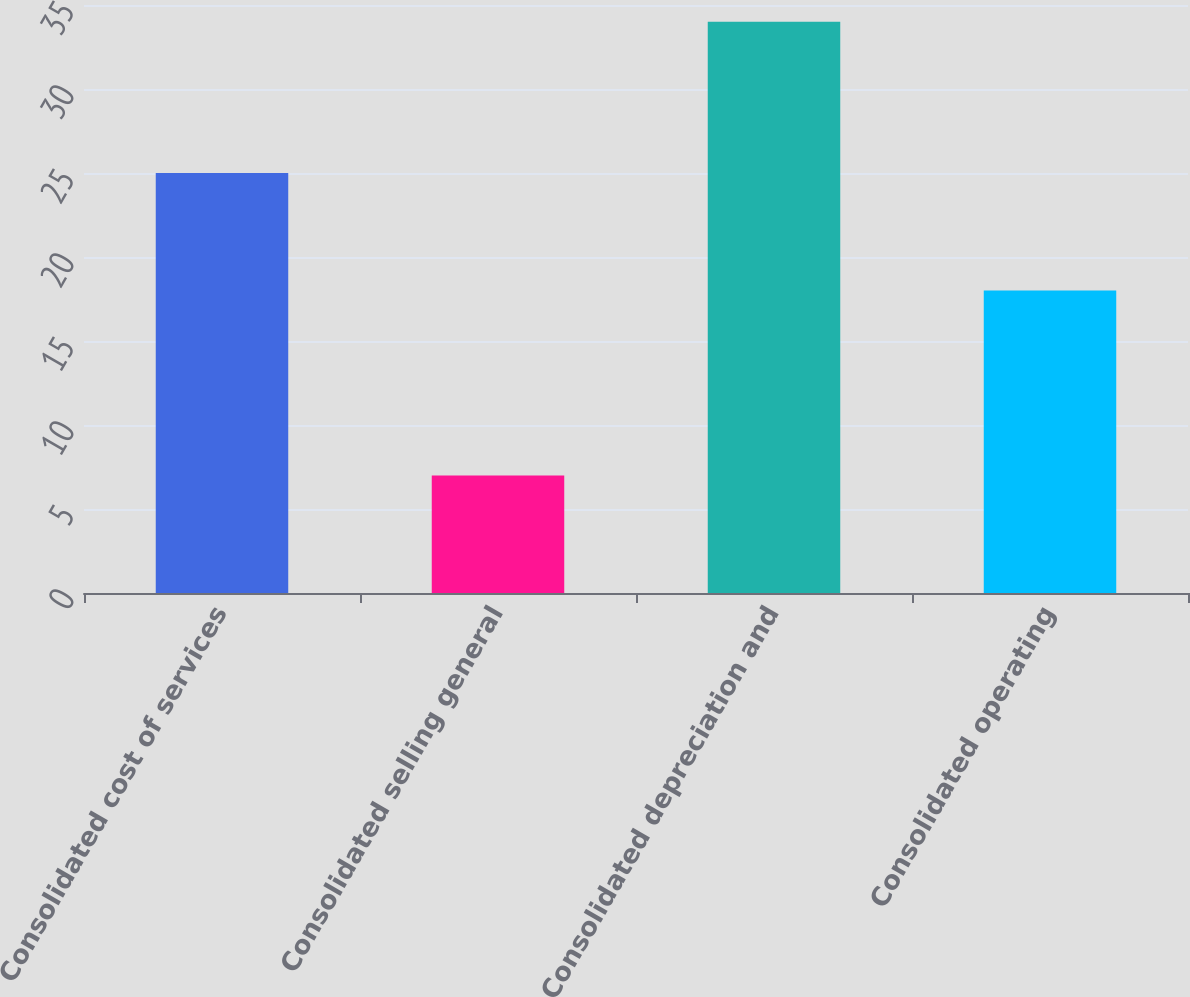<chart> <loc_0><loc_0><loc_500><loc_500><bar_chart><fcel>Consolidated cost of services<fcel>Consolidated selling general<fcel>Consolidated depreciation and<fcel>Consolidated operating<nl><fcel>25<fcel>7<fcel>34<fcel>18<nl></chart> 